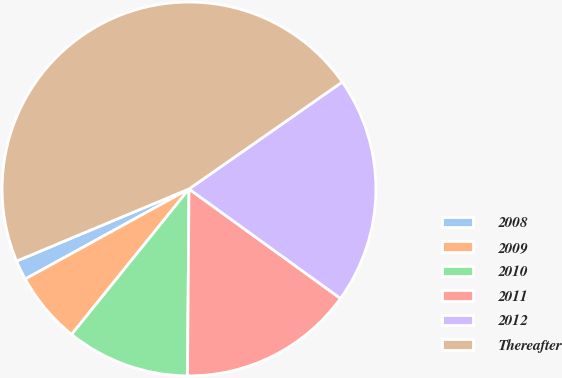Convert chart. <chart><loc_0><loc_0><loc_500><loc_500><pie_chart><fcel>2008<fcel>2009<fcel>2010<fcel>2011<fcel>2012<fcel>Thereafter<nl><fcel>1.7%<fcel>6.19%<fcel>10.68%<fcel>15.17%<fcel>19.66%<fcel>46.61%<nl></chart> 